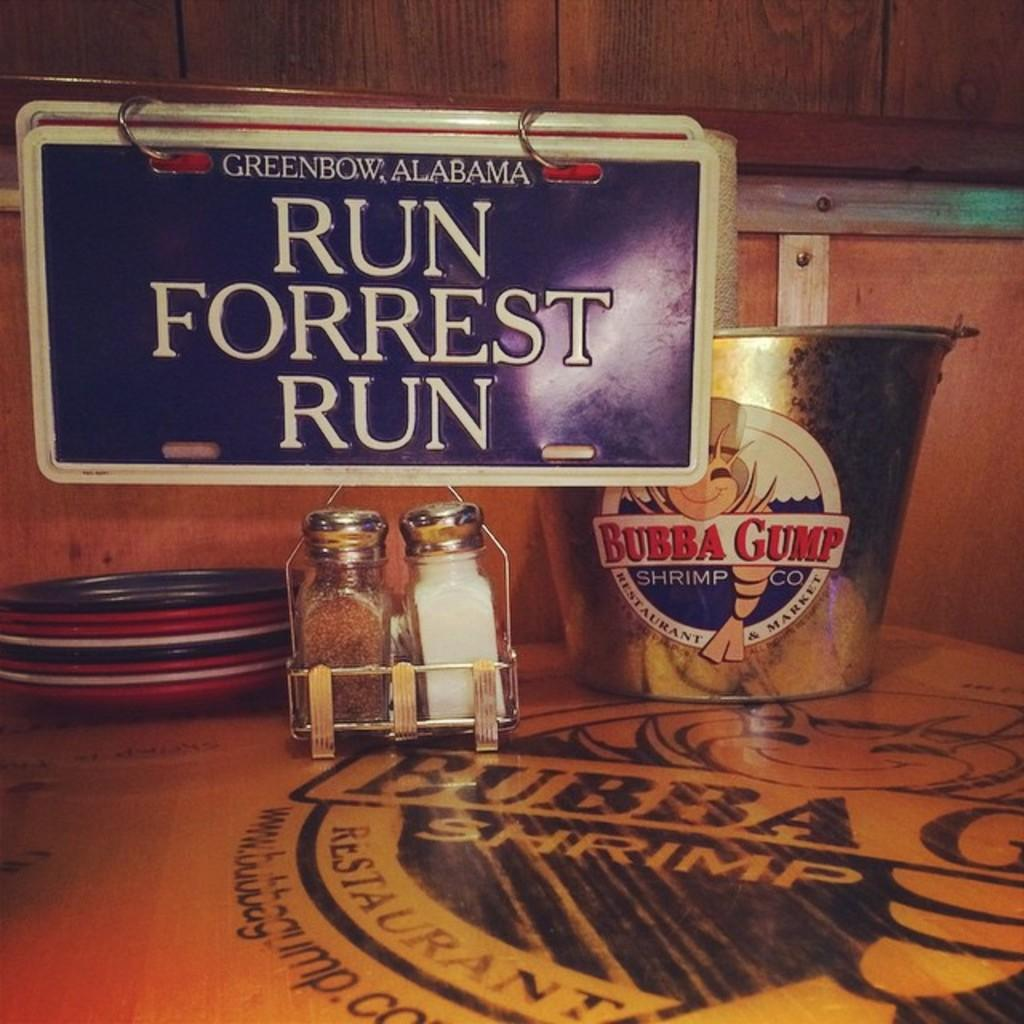What type of table is in the image? There is a wooden table in the image. What condiments are present on the table? There is table salt and a pepper bottle on the table. What is the purpose of the steel bucket on the table? The steel bucket is used to hold plates. Can you describe the name board in the image? There is a name board hanging on the back wall. What type of plants can be seen growing on the table in the image? There are no plants visible on the table in the image. 